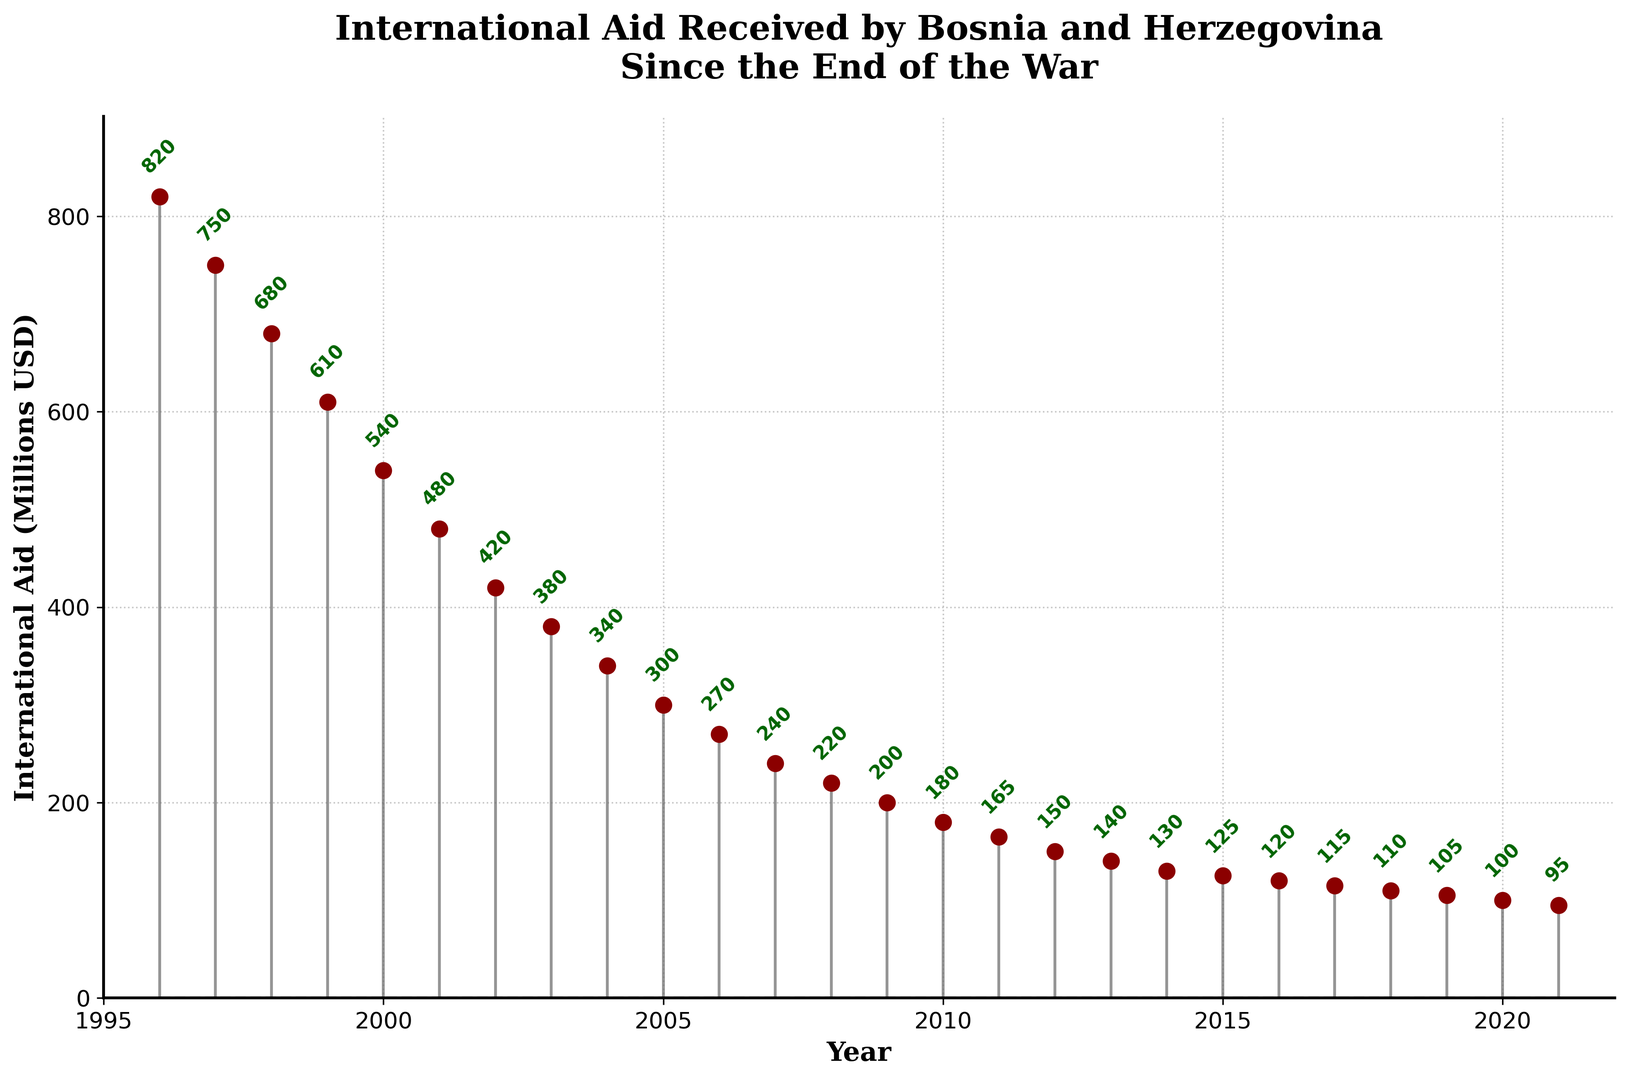what was the total amount of international aid received by Bosnia and Herzegovina from 1996 to 2021? Sum all the amounts of international aid received from 1996 to 2021: 820 + 750 + 680 + 610 + 540 + 480 + 420 + 380 + 340 + 300 + 270 + 240 + 220 + 200 + 180 + 165 + 150 + 140 + 130 + 125 + 120 + 115 + 110 + 105 + 100 + 95 =  8525
Answer: 8525 During which year was the international aid the highest, and what was the amount? Look at the peak point in the stem plot where the aid amount is the highest: It's in 1996 with 820 million USD
Answer: 1996, 820 million USD How much did the international aid decrease from 1996 to 1997? Subtract the international aid amount in 1997 from the amount in 1996: 820 - 750 = 70 million USD
Answer: 70 million USD In which year did the international aid fall below 500 million USD for the first time? Find the first year in the stem plot where the aid amount is below 500 million USD: It's in 2001
Answer: 2001 By how much did the international aid decrease from 1999 to 2021? Subtract the aid amount in 2021 from the amount in 1999: 610 - 95 = 515 million USD
Answer: 515 million USD Was the amount of international aid in 2005 greater than or less than the amount in 2002? Compare the aid amounts in 2005 and 2002. In 2005, it's 300 million USD and in 2002, it's 420 million USD. 300 is less than 420
Answer: Less than What is the average international aid received per year over the period from 1996 to 2021? Calculate the average by summing the total aid from 1996 to 2021 and dividing by the number of years: 8525 million USD / 26 years = approximately 327.88 million USD
Answer: 327.88 million USD What visual pattern can you observe in the trend of international aid over the years? The stem plot shows a consistent decline in the amount of international aid received by Bosnia and Herzegovina from 1996 to 2021
Answer: Consistent decline Which year had an international aid amount closest to 200 million USD, and what was the exact amount? Look for the year where the aid amount is closest to 200 million USD on the stem plot: It's 2008 with 220 million USD
Answer: 2008, 220 million USD How many years did Bosnia and Herzegovina receive annual international aid exceeding 500 million USD? Count the number of years in the stem plot where the aid amount exceeded 500 million USD: It's for 1996, 1997, 1998, 1999, and 2000, totaling 5 years
Answer: 5 years 